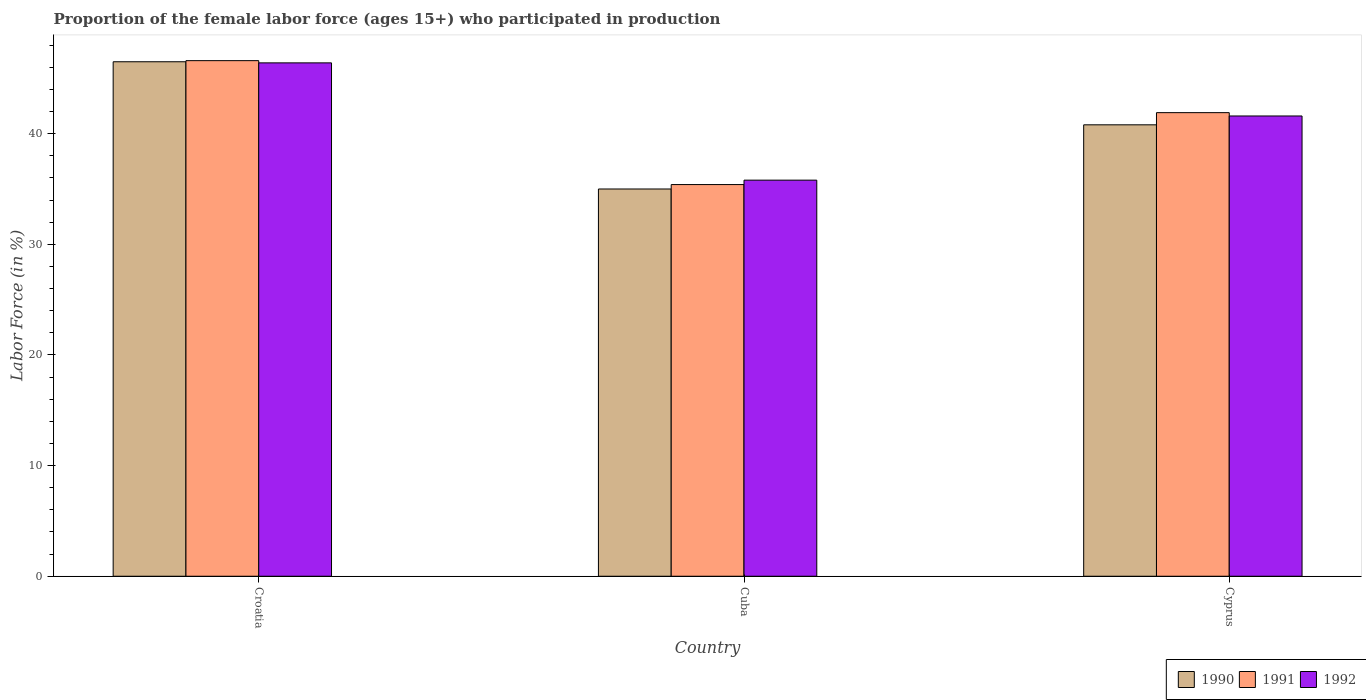How many different coloured bars are there?
Ensure brevity in your answer.  3. Are the number of bars on each tick of the X-axis equal?
Offer a very short reply. Yes. How many bars are there on the 3rd tick from the left?
Offer a terse response. 3. What is the label of the 3rd group of bars from the left?
Provide a succinct answer. Cyprus. What is the proportion of the female labor force who participated in production in 1990 in Cyprus?
Ensure brevity in your answer.  40.8. Across all countries, what is the maximum proportion of the female labor force who participated in production in 1991?
Keep it short and to the point. 46.6. Across all countries, what is the minimum proportion of the female labor force who participated in production in 1991?
Keep it short and to the point. 35.4. In which country was the proportion of the female labor force who participated in production in 1991 maximum?
Your response must be concise. Croatia. In which country was the proportion of the female labor force who participated in production in 1990 minimum?
Offer a terse response. Cuba. What is the total proportion of the female labor force who participated in production in 1991 in the graph?
Offer a very short reply. 123.9. What is the difference between the proportion of the female labor force who participated in production in 1990 in Cuba and that in Cyprus?
Your answer should be compact. -5.8. What is the difference between the proportion of the female labor force who participated in production in 1990 in Cyprus and the proportion of the female labor force who participated in production in 1991 in Cuba?
Provide a short and direct response. 5.4. What is the average proportion of the female labor force who participated in production in 1990 per country?
Give a very brief answer. 40.77. What is the difference between the proportion of the female labor force who participated in production of/in 1992 and proportion of the female labor force who participated in production of/in 1990 in Croatia?
Your answer should be compact. -0.1. What is the ratio of the proportion of the female labor force who participated in production in 1991 in Croatia to that in Cyprus?
Your answer should be compact. 1.11. Is the proportion of the female labor force who participated in production in 1991 in Cuba less than that in Cyprus?
Offer a terse response. Yes. Is the difference between the proportion of the female labor force who participated in production in 1992 in Croatia and Cuba greater than the difference between the proportion of the female labor force who participated in production in 1990 in Croatia and Cuba?
Your response must be concise. No. What is the difference between the highest and the second highest proportion of the female labor force who participated in production in 1992?
Keep it short and to the point. 5.8. Is the sum of the proportion of the female labor force who participated in production in 1991 in Cuba and Cyprus greater than the maximum proportion of the female labor force who participated in production in 1990 across all countries?
Give a very brief answer. Yes. What is the difference between two consecutive major ticks on the Y-axis?
Keep it short and to the point. 10. Are the values on the major ticks of Y-axis written in scientific E-notation?
Make the answer very short. No. Does the graph contain any zero values?
Offer a very short reply. No. How many legend labels are there?
Your answer should be compact. 3. What is the title of the graph?
Your response must be concise. Proportion of the female labor force (ages 15+) who participated in production. What is the label or title of the X-axis?
Keep it short and to the point. Country. What is the label or title of the Y-axis?
Make the answer very short. Labor Force (in %). What is the Labor Force (in %) of 1990 in Croatia?
Give a very brief answer. 46.5. What is the Labor Force (in %) of 1991 in Croatia?
Your answer should be very brief. 46.6. What is the Labor Force (in %) of 1992 in Croatia?
Keep it short and to the point. 46.4. What is the Labor Force (in %) of 1991 in Cuba?
Provide a succinct answer. 35.4. What is the Labor Force (in %) of 1992 in Cuba?
Your answer should be compact. 35.8. What is the Labor Force (in %) in 1990 in Cyprus?
Your answer should be very brief. 40.8. What is the Labor Force (in %) in 1991 in Cyprus?
Your response must be concise. 41.9. What is the Labor Force (in %) of 1992 in Cyprus?
Offer a terse response. 41.6. Across all countries, what is the maximum Labor Force (in %) of 1990?
Keep it short and to the point. 46.5. Across all countries, what is the maximum Labor Force (in %) in 1991?
Your answer should be very brief. 46.6. Across all countries, what is the maximum Labor Force (in %) in 1992?
Make the answer very short. 46.4. Across all countries, what is the minimum Labor Force (in %) in 1991?
Ensure brevity in your answer.  35.4. Across all countries, what is the minimum Labor Force (in %) of 1992?
Your response must be concise. 35.8. What is the total Labor Force (in %) in 1990 in the graph?
Provide a succinct answer. 122.3. What is the total Labor Force (in %) in 1991 in the graph?
Provide a short and direct response. 123.9. What is the total Labor Force (in %) of 1992 in the graph?
Offer a very short reply. 123.8. What is the difference between the Labor Force (in %) of 1990 in Croatia and that in Cuba?
Keep it short and to the point. 11.5. What is the difference between the Labor Force (in %) of 1991 in Croatia and that in Cuba?
Keep it short and to the point. 11.2. What is the difference between the Labor Force (in %) of 1991 in Croatia and that in Cyprus?
Your answer should be very brief. 4.7. What is the difference between the Labor Force (in %) of 1990 in Cuba and that in Cyprus?
Give a very brief answer. -5.8. What is the difference between the Labor Force (in %) of 1991 in Cuba and that in Cyprus?
Offer a terse response. -6.5. What is the difference between the Labor Force (in %) in 1992 in Cuba and that in Cyprus?
Offer a terse response. -5.8. What is the difference between the Labor Force (in %) in 1990 in Croatia and the Labor Force (in %) in 1991 in Cuba?
Provide a short and direct response. 11.1. What is the difference between the Labor Force (in %) of 1990 in Croatia and the Labor Force (in %) of 1992 in Cuba?
Your answer should be very brief. 10.7. What is the difference between the Labor Force (in %) of 1990 in Croatia and the Labor Force (in %) of 1992 in Cyprus?
Offer a terse response. 4.9. What is the average Labor Force (in %) in 1990 per country?
Offer a very short reply. 40.77. What is the average Labor Force (in %) of 1991 per country?
Make the answer very short. 41.3. What is the average Labor Force (in %) in 1992 per country?
Keep it short and to the point. 41.27. What is the difference between the Labor Force (in %) in 1990 and Labor Force (in %) in 1991 in Croatia?
Offer a very short reply. -0.1. What is the difference between the Labor Force (in %) of 1990 and Labor Force (in %) of 1992 in Croatia?
Give a very brief answer. 0.1. What is the difference between the Labor Force (in %) in 1990 and Labor Force (in %) in 1991 in Cuba?
Keep it short and to the point. -0.4. What is the difference between the Labor Force (in %) in 1991 and Labor Force (in %) in 1992 in Cuba?
Your answer should be very brief. -0.4. What is the ratio of the Labor Force (in %) of 1990 in Croatia to that in Cuba?
Your answer should be compact. 1.33. What is the ratio of the Labor Force (in %) of 1991 in Croatia to that in Cuba?
Offer a very short reply. 1.32. What is the ratio of the Labor Force (in %) of 1992 in Croatia to that in Cuba?
Give a very brief answer. 1.3. What is the ratio of the Labor Force (in %) in 1990 in Croatia to that in Cyprus?
Keep it short and to the point. 1.14. What is the ratio of the Labor Force (in %) of 1991 in Croatia to that in Cyprus?
Give a very brief answer. 1.11. What is the ratio of the Labor Force (in %) in 1992 in Croatia to that in Cyprus?
Your response must be concise. 1.12. What is the ratio of the Labor Force (in %) of 1990 in Cuba to that in Cyprus?
Offer a very short reply. 0.86. What is the ratio of the Labor Force (in %) of 1991 in Cuba to that in Cyprus?
Ensure brevity in your answer.  0.84. What is the ratio of the Labor Force (in %) in 1992 in Cuba to that in Cyprus?
Provide a short and direct response. 0.86. What is the difference between the highest and the second highest Labor Force (in %) of 1990?
Offer a very short reply. 5.7. What is the difference between the highest and the second highest Labor Force (in %) of 1991?
Make the answer very short. 4.7. What is the difference between the highest and the second highest Labor Force (in %) in 1992?
Give a very brief answer. 4.8. 